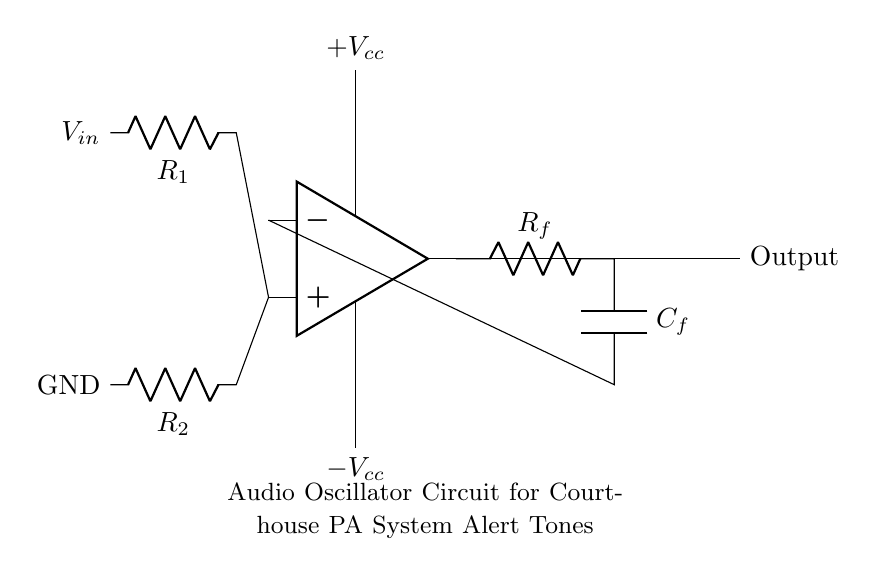What type of amplifier is used in this circuit? The circuit uses an operational amplifier (op-amp). The symbol for the op-amp clearly denotes it as the main component of the audio oscillator.
Answer: operational amplifier What are the values of the resistors in the input and feedback networks? The circuit shows resistor labels as R1 and R2 for the input network and Rf for the feedback network. However, their numeric values are not provided in the diagram, only their labels are visible.
Answer: R1, R2, Rf How many capacitors are used in this circuit? The diagram includes only one capacitor labeled C_f in the feedback network, indicating that there is one capacitor involved in the oscillator function.
Answer: one What is the role of the capacitor in this audio oscillator circuit? The capacitor (C_f) in feedback networks is crucial for determining the frequency of oscillation by working alongside the resistors. It charges and discharges, creating the oscillation necessary for generating alert tones.
Answer: frequency determination What is the output of this oscillator circuit? The output is clearly labeled as "Output" next to the op-amp, indicating that this is where the generated alert tones can be accessed. This provides the audio signal needed for the PA system.
Answer: Output What are the power supply voltages connected to this circuit? The power supply has both a positive and a negative voltage indicated as +V_cc and -V_cc, respectively. These are necessary to power the op-amp for its operation.
Answer: +V_cc and -V_cc 